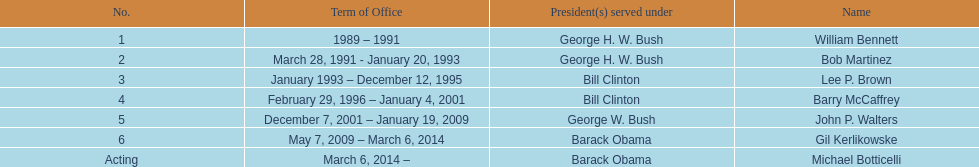How long did the first director serve in office? 2 years. 